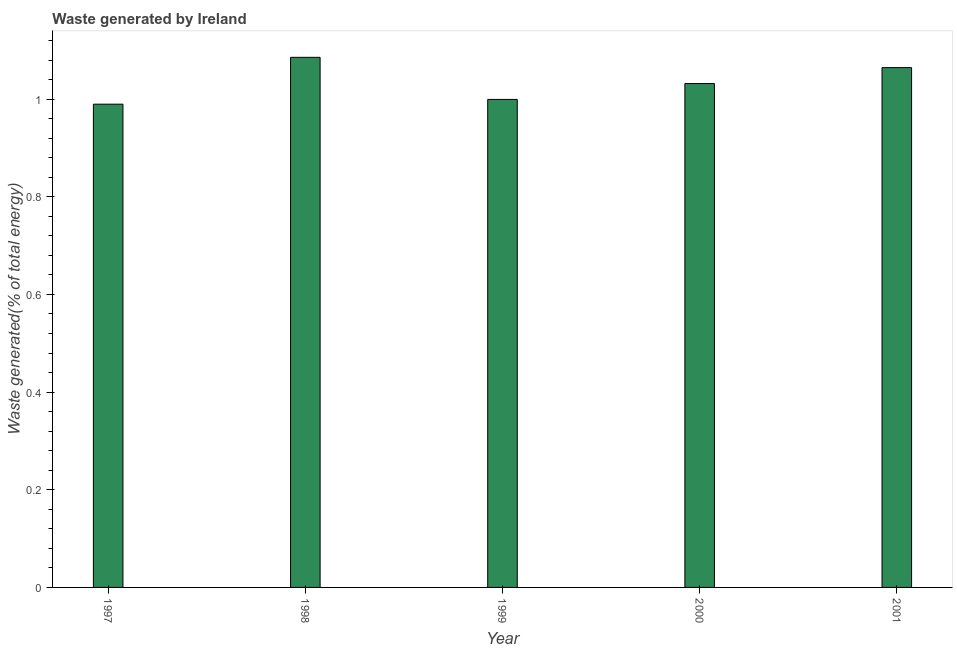Does the graph contain any zero values?
Your answer should be very brief. No. Does the graph contain grids?
Your answer should be compact. No. What is the title of the graph?
Provide a short and direct response. Waste generated by Ireland. What is the label or title of the X-axis?
Provide a short and direct response. Year. What is the label or title of the Y-axis?
Offer a terse response. Waste generated(% of total energy). What is the amount of waste generated in 2000?
Make the answer very short. 1.03. Across all years, what is the maximum amount of waste generated?
Ensure brevity in your answer.  1.09. Across all years, what is the minimum amount of waste generated?
Your answer should be compact. 0.99. What is the sum of the amount of waste generated?
Provide a short and direct response. 5.17. What is the difference between the amount of waste generated in 1997 and 1999?
Provide a short and direct response. -0.01. What is the average amount of waste generated per year?
Your answer should be very brief. 1.03. What is the median amount of waste generated?
Offer a very short reply. 1.03. Do a majority of the years between 2000 and 1997 (inclusive) have amount of waste generated greater than 1 %?
Give a very brief answer. Yes. Is the difference between the amount of waste generated in 1997 and 1998 greater than the difference between any two years?
Give a very brief answer. Yes. What is the difference between the highest and the second highest amount of waste generated?
Offer a terse response. 0.02. How many years are there in the graph?
Keep it short and to the point. 5. What is the difference between two consecutive major ticks on the Y-axis?
Your answer should be very brief. 0.2. What is the Waste generated(% of total energy) in 1997?
Your response must be concise. 0.99. What is the Waste generated(% of total energy) in 1998?
Keep it short and to the point. 1.09. What is the Waste generated(% of total energy) in 1999?
Keep it short and to the point. 1. What is the Waste generated(% of total energy) in 2000?
Offer a very short reply. 1.03. What is the Waste generated(% of total energy) of 2001?
Your answer should be very brief. 1.06. What is the difference between the Waste generated(% of total energy) in 1997 and 1998?
Provide a short and direct response. -0.1. What is the difference between the Waste generated(% of total energy) in 1997 and 1999?
Provide a succinct answer. -0.01. What is the difference between the Waste generated(% of total energy) in 1997 and 2000?
Ensure brevity in your answer.  -0.04. What is the difference between the Waste generated(% of total energy) in 1997 and 2001?
Your response must be concise. -0.07. What is the difference between the Waste generated(% of total energy) in 1998 and 1999?
Make the answer very short. 0.09. What is the difference between the Waste generated(% of total energy) in 1998 and 2000?
Your response must be concise. 0.05. What is the difference between the Waste generated(% of total energy) in 1998 and 2001?
Ensure brevity in your answer.  0.02. What is the difference between the Waste generated(% of total energy) in 1999 and 2000?
Make the answer very short. -0.03. What is the difference between the Waste generated(% of total energy) in 1999 and 2001?
Your response must be concise. -0.07. What is the difference between the Waste generated(% of total energy) in 2000 and 2001?
Make the answer very short. -0.03. What is the ratio of the Waste generated(% of total energy) in 1997 to that in 1998?
Provide a short and direct response. 0.91. What is the ratio of the Waste generated(% of total energy) in 1997 to that in 2001?
Provide a succinct answer. 0.93. What is the ratio of the Waste generated(% of total energy) in 1998 to that in 1999?
Your answer should be very brief. 1.09. What is the ratio of the Waste generated(% of total energy) in 1998 to that in 2000?
Offer a very short reply. 1.05. What is the ratio of the Waste generated(% of total energy) in 1999 to that in 2001?
Give a very brief answer. 0.94. 